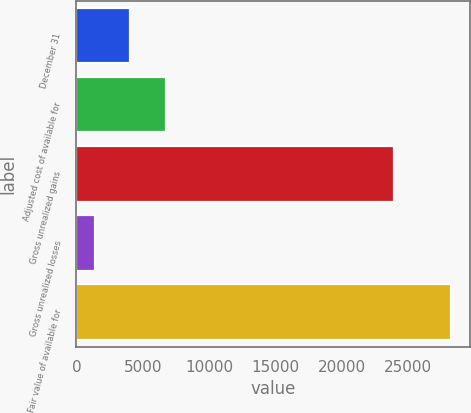<chart> <loc_0><loc_0><loc_500><loc_500><bar_chart><fcel>December 31<fcel>Adjusted cost of available for<fcel>Gross unrealized gains<fcel>Gross unrealized losses<fcel>Fair value of available for<nl><fcel>4058.9<fcel>6740.8<fcel>23947<fcel>1377<fcel>28196<nl></chart> 